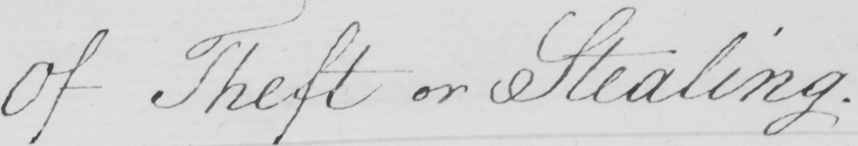What does this handwritten line say? Of Theft or Stealing . 